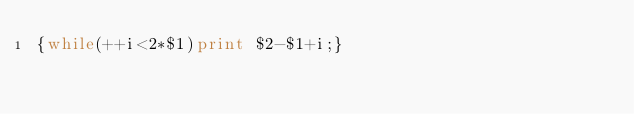<code> <loc_0><loc_0><loc_500><loc_500><_Awk_>{while(++i<2*$1)print $2-$1+i;}</code> 